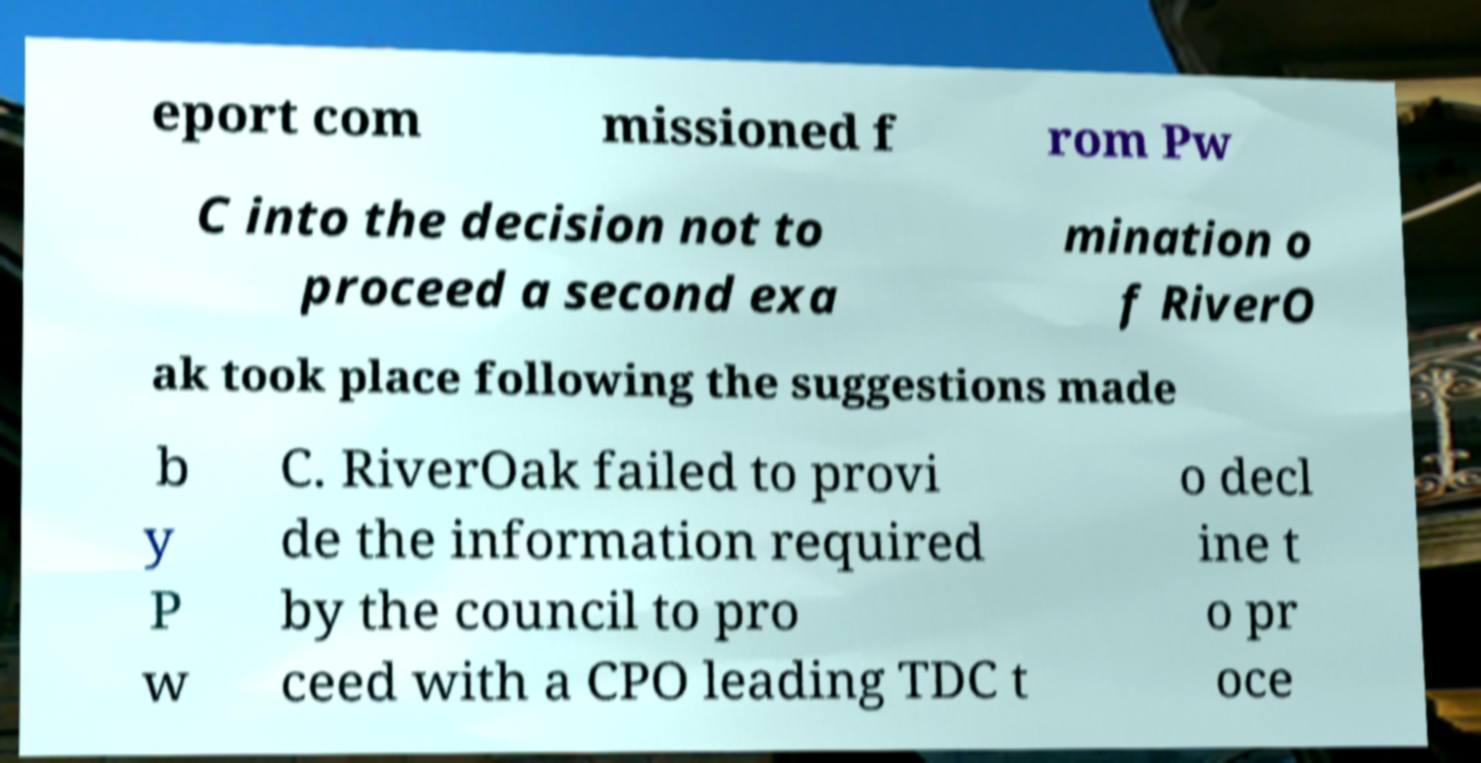Can you accurately transcribe the text from the provided image for me? eport com missioned f rom Pw C into the decision not to proceed a second exa mination o f RiverO ak took place following the suggestions made b y P w C. RiverOak failed to provi de the information required by the council to pro ceed with a CPO leading TDC t o decl ine t o pr oce 